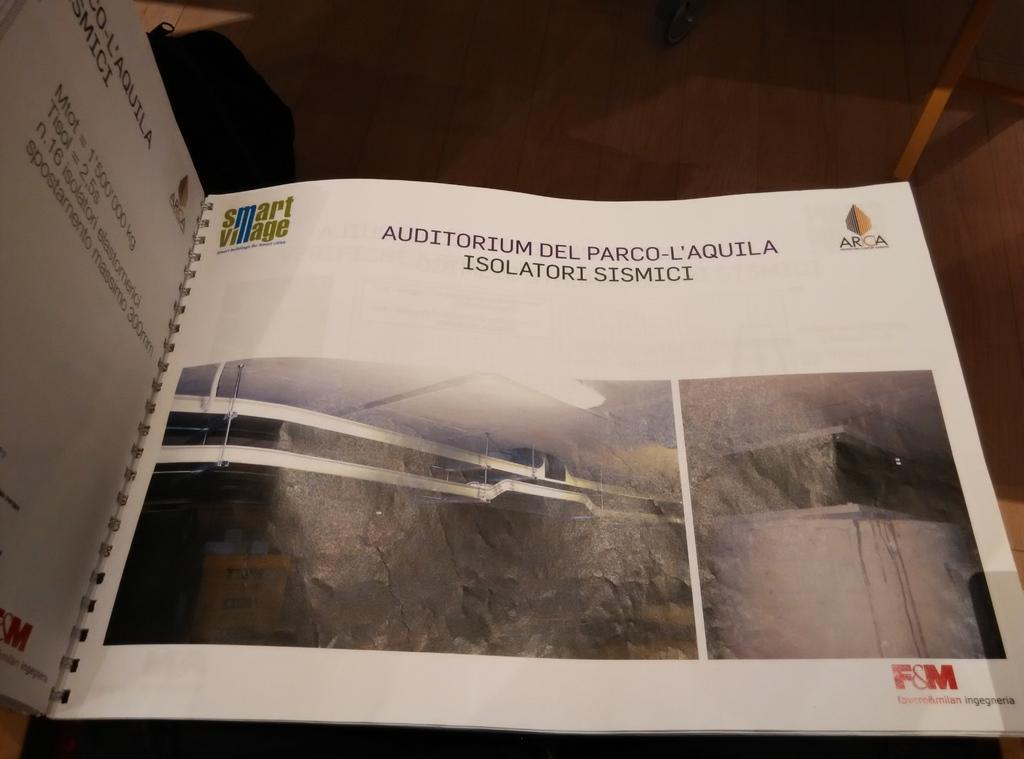What type of village is mentioned in the top left?
Make the answer very short. Smart. 